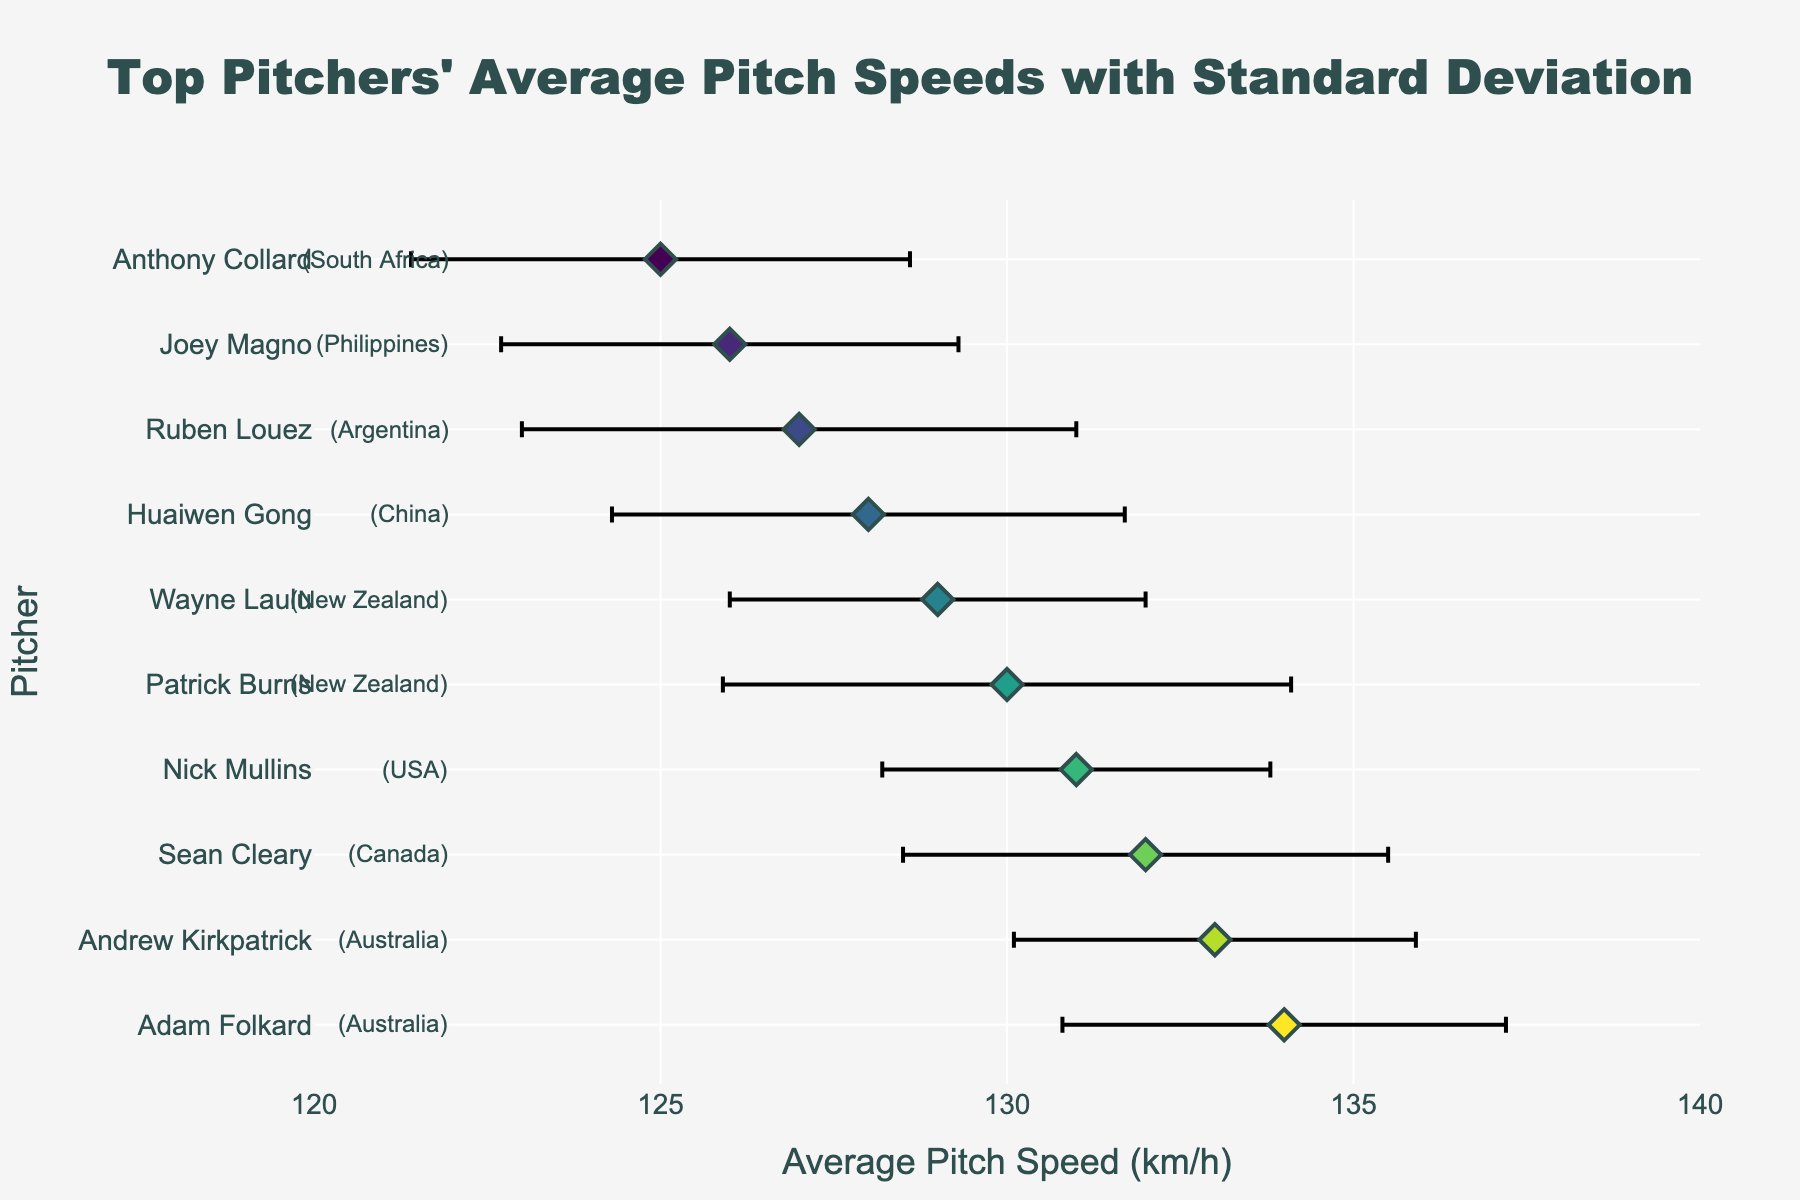What is the title of the plot? The title of the plot is located at the top of the figure. It is often the largest text and distinctively styled compared to other text elements.
Answer: Top Pitchers' Average Pitch Speeds with Standard Deviation What is the average pitch speed of Adam Folkard? Adam Folkard is listed first in the sorted figure due to having the highest average speed. His average pitch speed is shown directly on the x-axis.
Answer: 134 km/h Who has the lowest pitch speed among the top pitchers? The pitcher with the lowest pitch speed will be at the bottom of the figure since the data is sorted by decreasing pitch speed. Anthony Collard appears last.
Answer: Anthony Collard What is the standard deviation of Andrew Kirkpatrick’s pitch speed? Andrew Kirkpatrick can be identified in the list, and his pitch speed's standard deviation is shown along with his name in the figure.
Answer: 2.9 km/h How many pitchers have an average pitch speed greater than 130 km/h? By counting the number of data points (names) above the value 130 km/h on the x-axis, we can determine the number of pitchers with average speeds exceeding this threshold.
Answer: 5 Which pitcher from New Zealand has a lower average pitch speed? There are two pitchers from New Zealand listed: Patrick Burns and Wayne Laulu. Comparing their average speeds, we see Wayne Laulu has the lower average.
Answer: Wayne Laulu What is the range of average pitch speeds shown in the figure? The range is calculated by finding the difference between the highest and lowest average speeds. Here, the highest is 134 km/h (Adam Folkard) and the lowest is 125 km/h (Anthony Collard).
Answer: 9 km/h Which pitcher has the highest standard deviation in pitch speed? By observing the lengths of the error bars, we can identify the pitcher with the longest error bar. This would correspond to the highest standard deviation. Patrick Burns has the longest error bar.
Answer: Patrick Burns Compare the average pitch speeds of Sean Cleary and Nick Mullins. Who is faster? We look at the average pitch speeds for Sean Cleary and Nick Mullins. Sean Cleary's average pitch speed is 132 km/h while Nick Mullins’ is 131 km/h.
Answer: Sean Cleary 